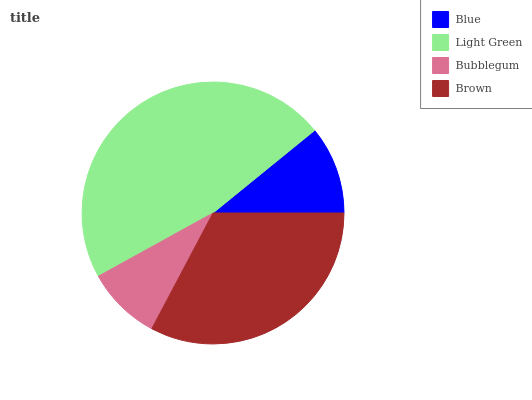Is Bubblegum the minimum?
Answer yes or no. Yes. Is Light Green the maximum?
Answer yes or no. Yes. Is Light Green the minimum?
Answer yes or no. No. Is Bubblegum the maximum?
Answer yes or no. No. Is Light Green greater than Bubblegum?
Answer yes or no. Yes. Is Bubblegum less than Light Green?
Answer yes or no. Yes. Is Bubblegum greater than Light Green?
Answer yes or no. No. Is Light Green less than Bubblegum?
Answer yes or no. No. Is Brown the high median?
Answer yes or no. Yes. Is Blue the low median?
Answer yes or no. Yes. Is Bubblegum the high median?
Answer yes or no. No. Is Bubblegum the low median?
Answer yes or no. No. 